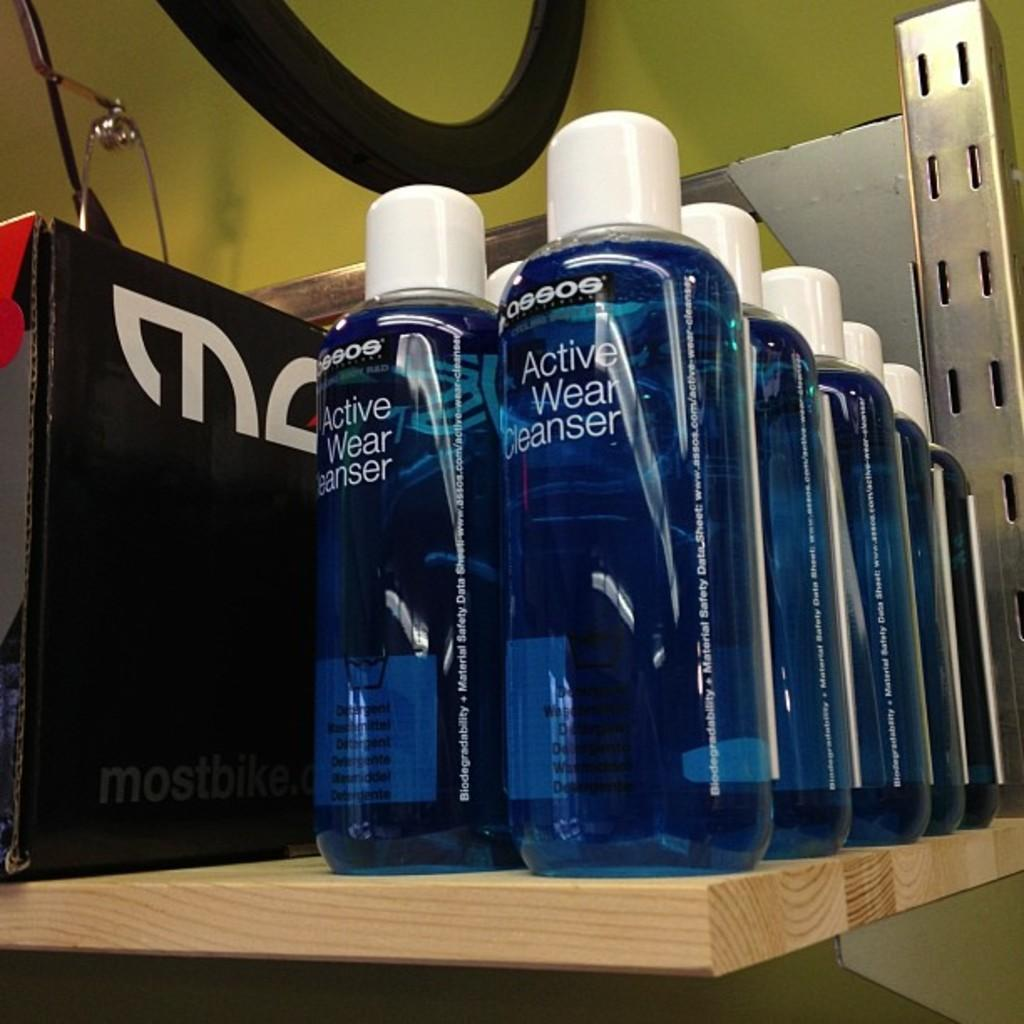Provide a one-sentence caption for the provided image. Two rows of bottles filled with blue Active Wear Cleanser on a shelf. 